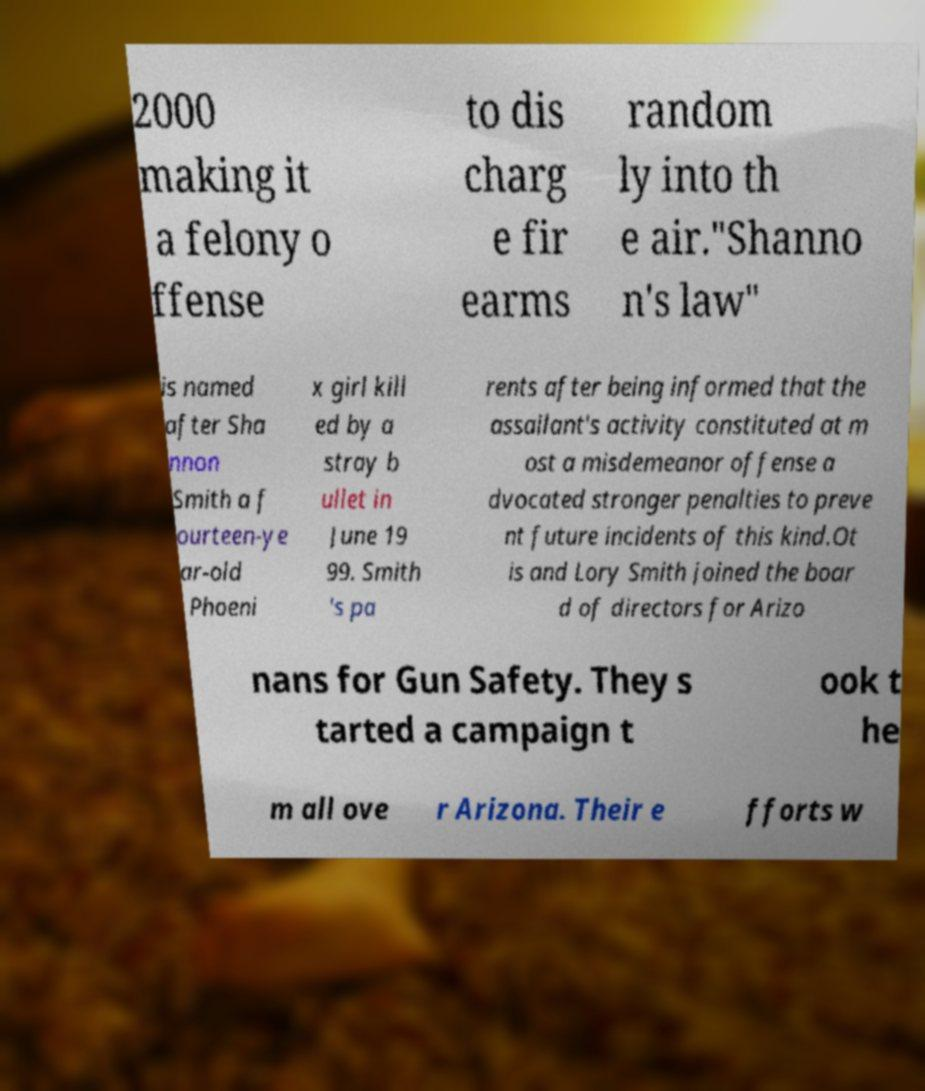Please read and relay the text visible in this image. What does it say? 2000 making it a felony o ffense to dis charg e fir earms random ly into th e air."Shanno n's law" is named after Sha nnon Smith a f ourteen-ye ar-old Phoeni x girl kill ed by a stray b ullet in June 19 99. Smith 's pa rents after being informed that the assailant's activity constituted at m ost a misdemeanor offense a dvocated stronger penalties to preve nt future incidents of this kind.Ot is and Lory Smith joined the boar d of directors for Arizo nans for Gun Safety. They s tarted a campaign t ook t he m all ove r Arizona. Their e fforts w 